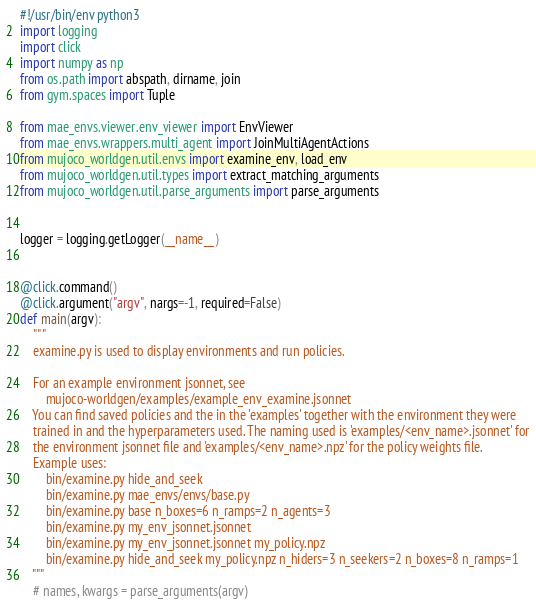Convert code to text. <code><loc_0><loc_0><loc_500><loc_500><_Python_>#!/usr/bin/env python3
import logging
import click
import numpy as np
from os.path import abspath, dirname, join
from gym.spaces import Tuple

from mae_envs.viewer.env_viewer import EnvViewer
from mae_envs.wrappers.multi_agent import JoinMultiAgentActions
from mujoco_worldgen.util.envs import examine_env, load_env
from mujoco_worldgen.util.types import extract_matching_arguments
from mujoco_worldgen.util.parse_arguments import parse_arguments


logger = logging.getLogger(__name__)


@click.command()
@click.argument("argv", nargs=-1, required=False)
def main(argv):
    """
    examine.py is used to display environments and run policies.

    For an example environment jsonnet, see
        mujoco-worldgen/examples/example_env_examine.jsonnet
    You can find saved policies and the in the 'examples' together with the environment they were
    trained in and the hyperparameters used. The naming used is 'examples/<env_name>.jsonnet' for
    the environment jsonnet file and 'examples/<env_name>.npz' for the policy weights file.
    Example uses:
        bin/examine.py hide_and_seek
        bin/examine.py mae_envs/envs/base.py
        bin/examine.py base n_boxes=6 n_ramps=2 n_agents=3
        bin/examine.py my_env_jsonnet.jsonnet
        bin/examine.py my_env_jsonnet.jsonnet my_policy.npz
        bin/examine.py hide_and_seek my_policy.npz n_hiders=3 n_seekers=2 n_boxes=8 n_ramps=1
    """
    # names, kwargs = parse_arguments(argv)</code> 